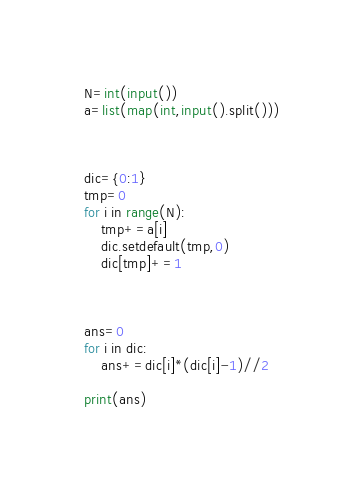<code> <loc_0><loc_0><loc_500><loc_500><_Python_>N=int(input())
a=list(map(int,input().split()))



dic={0:1}
tmp=0
for i in range(N):
    tmp+=a[i]
    dic.setdefault(tmp,0)
    dic[tmp]+=1



ans=0
for i in dic:
    ans+=dic[i]*(dic[i]-1)//2

print(ans)</code> 